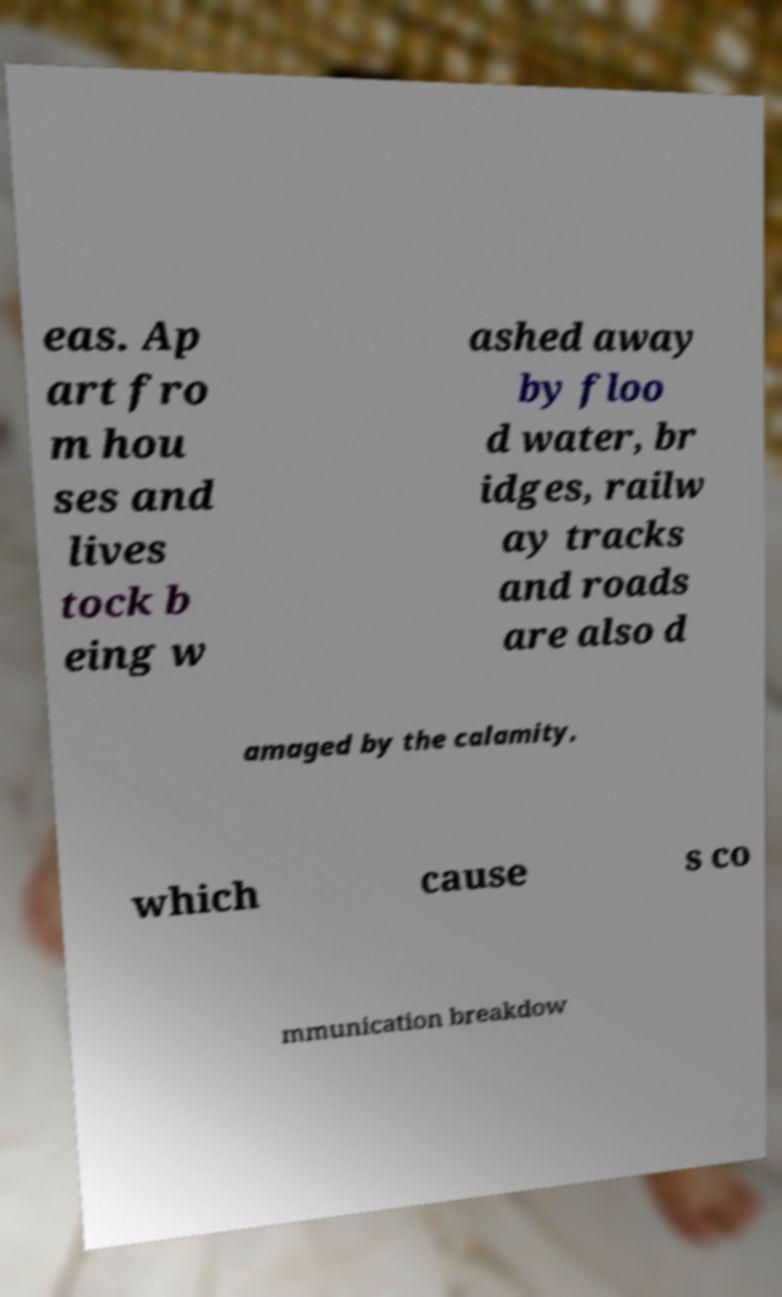Please read and relay the text visible in this image. What does it say? eas. Ap art fro m hou ses and lives tock b eing w ashed away by floo d water, br idges, railw ay tracks and roads are also d amaged by the calamity, which cause s co mmunication breakdow 